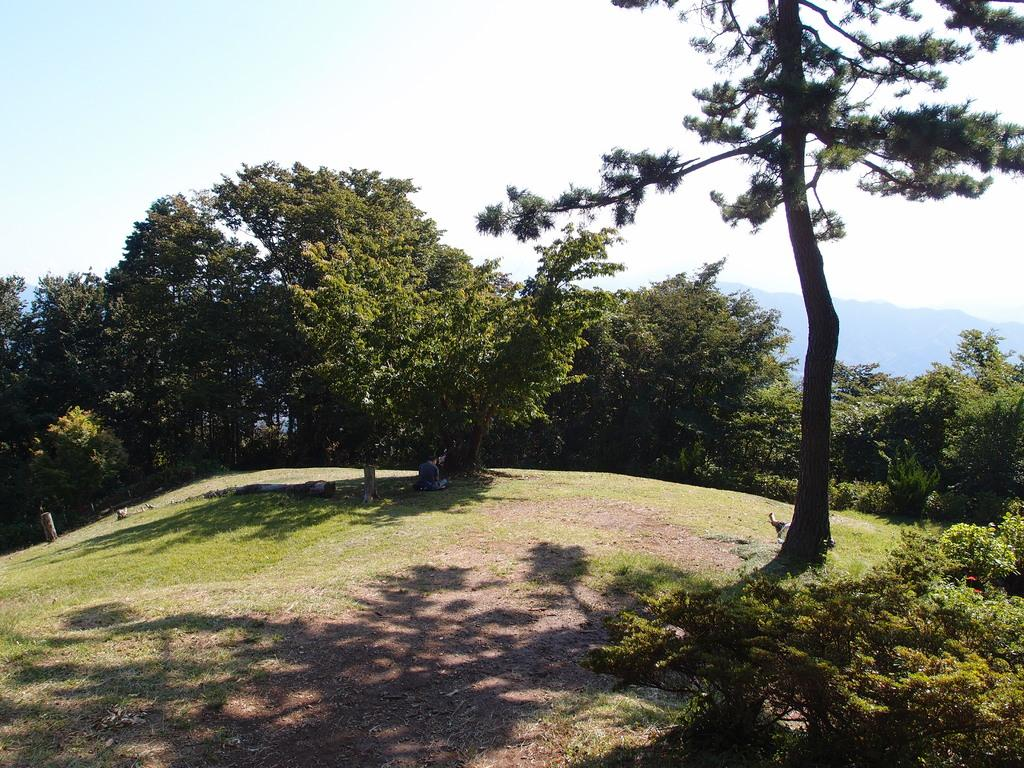What type of vegetation can be seen in the image? There is grass and trees in the image. What type of terrain is visible in the image? There are hills in the image. What is visible in the background of the image? The sky is visible in the background of the image. What type of tin can be seen in the image? There is no tin present in the image. What might surprise the trees in the image? Trees cannot experience surprise, as they are inanimate objects. 